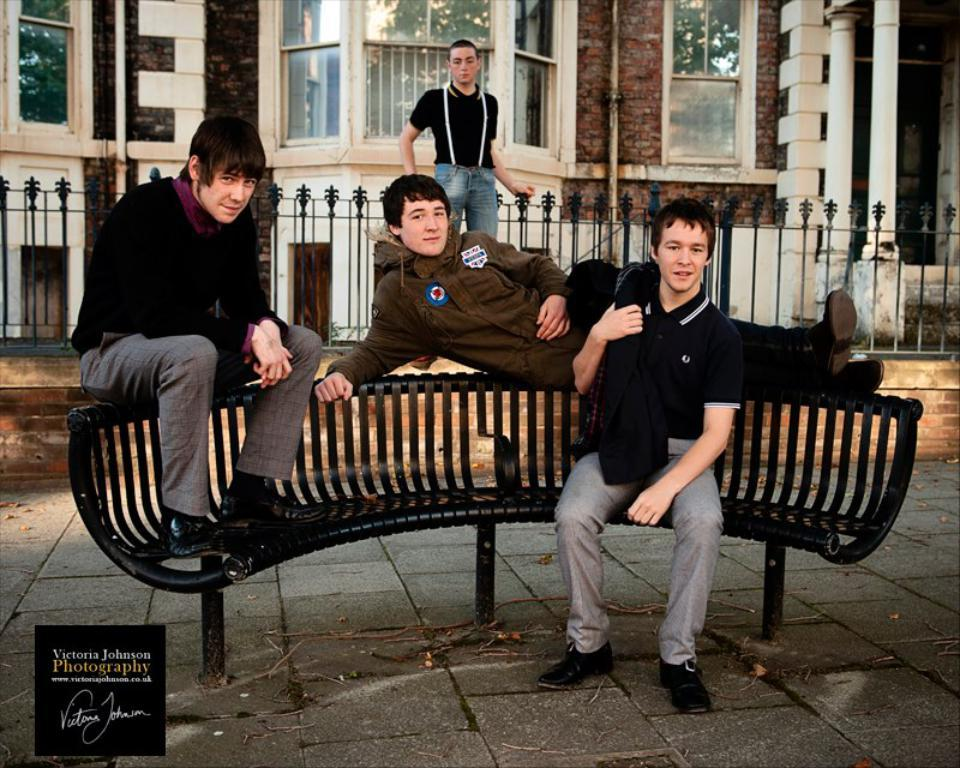What type of structure is visible in the image? There is a building in the image. What other objects can be seen in the image? There are pipelines and grills visible in the image. What is the person standing on in the image? The person is standing on a grill in the image. What are the other people in the image doing? There are persons sitting on a bench in the image. What type of fang can be seen on the person sitting on the bench? There are no fangs visible on any person in the image. What color is the ink used to write on the pipelines? There is no writing or ink present on the pipelines in the image. 